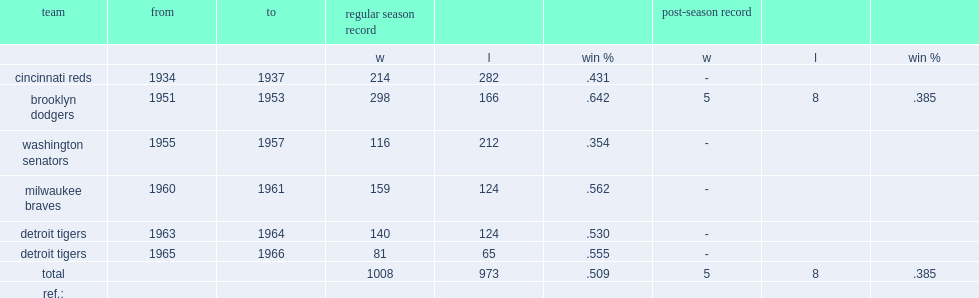What was the won-lost record in regular season of cincinnati reds ? 214.0 282.0. 